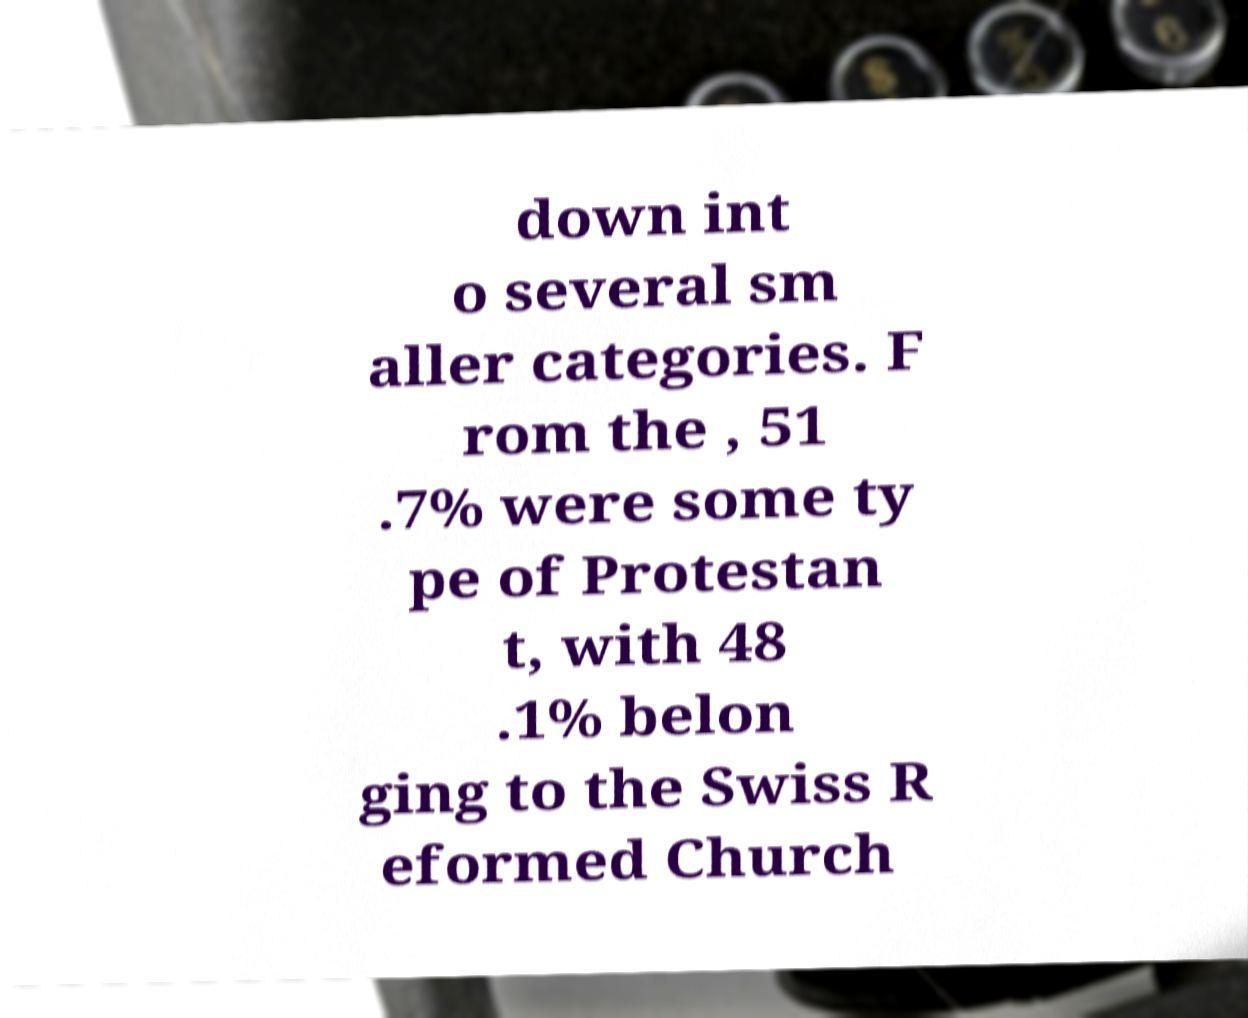What messages or text are displayed in this image? I need them in a readable, typed format. down int o several sm aller categories. F rom the , 51 .7% were some ty pe of Protestan t, with 48 .1% belon ging to the Swiss R eformed Church 